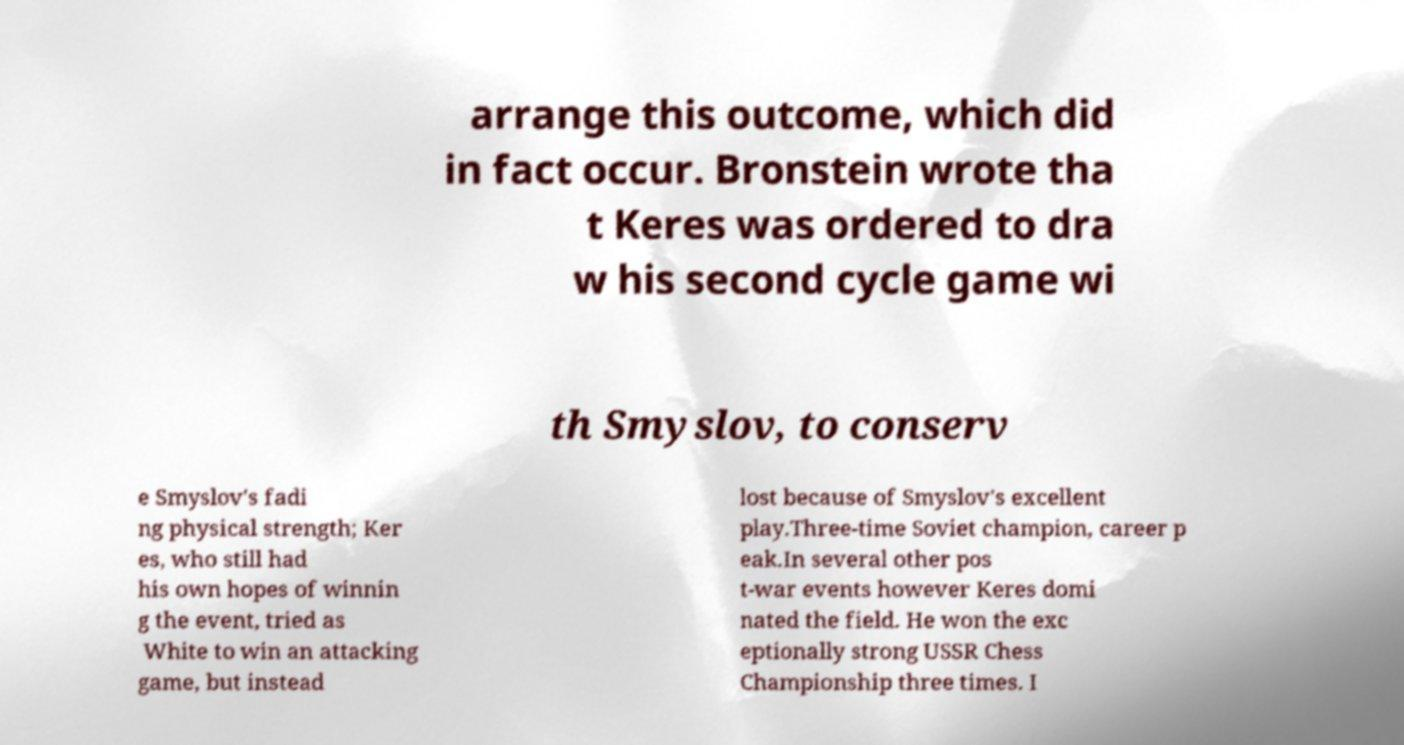What messages or text are displayed in this image? I need them in a readable, typed format. arrange this outcome, which did in fact occur. Bronstein wrote tha t Keres was ordered to dra w his second cycle game wi th Smyslov, to conserv e Smyslov's fadi ng physical strength; Ker es, who still had his own hopes of winnin g the event, tried as White to win an attacking game, but instead lost because of Smyslov's excellent play.Three-time Soviet champion, career p eak.In several other pos t-war events however Keres domi nated the field. He won the exc eptionally strong USSR Chess Championship three times. I 